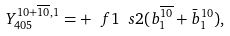Convert formula to latex. <formula><loc_0><loc_0><loc_500><loc_500>Y ^ { 1 0 + \overline { 1 0 } , 1 } _ { 4 0 5 } = + \ f { 1 } { \ s { 2 } } ( b ^ { \overline { 1 0 } } _ { 1 } + \bar { b } ^ { 1 0 } _ { 1 } ) ,</formula> 